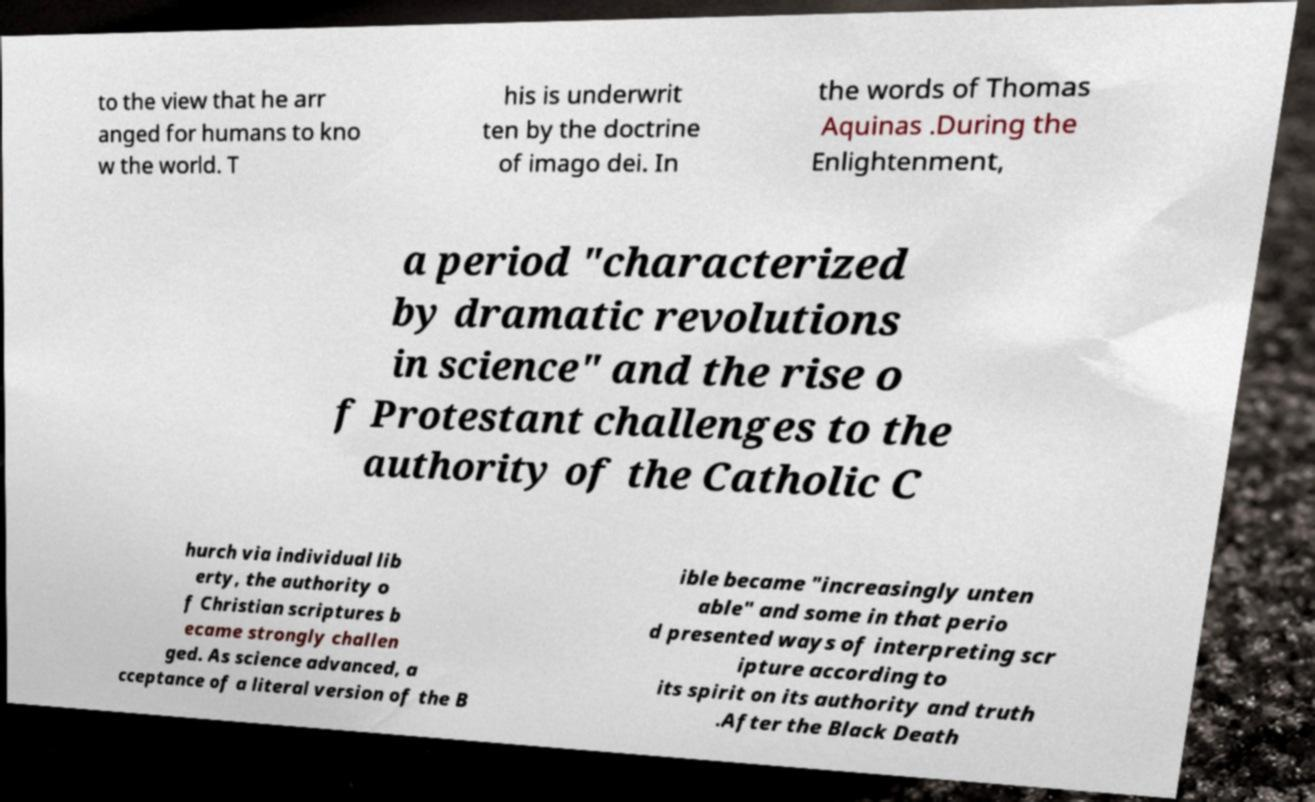I need the written content from this picture converted into text. Can you do that? to the view that he arr anged for humans to kno w the world. T his is underwrit ten by the doctrine of imago dei. In the words of Thomas Aquinas .During the Enlightenment, a period "characterized by dramatic revolutions in science" and the rise o f Protestant challenges to the authority of the Catholic C hurch via individual lib erty, the authority o f Christian scriptures b ecame strongly challen ged. As science advanced, a cceptance of a literal version of the B ible became "increasingly unten able" and some in that perio d presented ways of interpreting scr ipture according to its spirit on its authority and truth .After the Black Death 